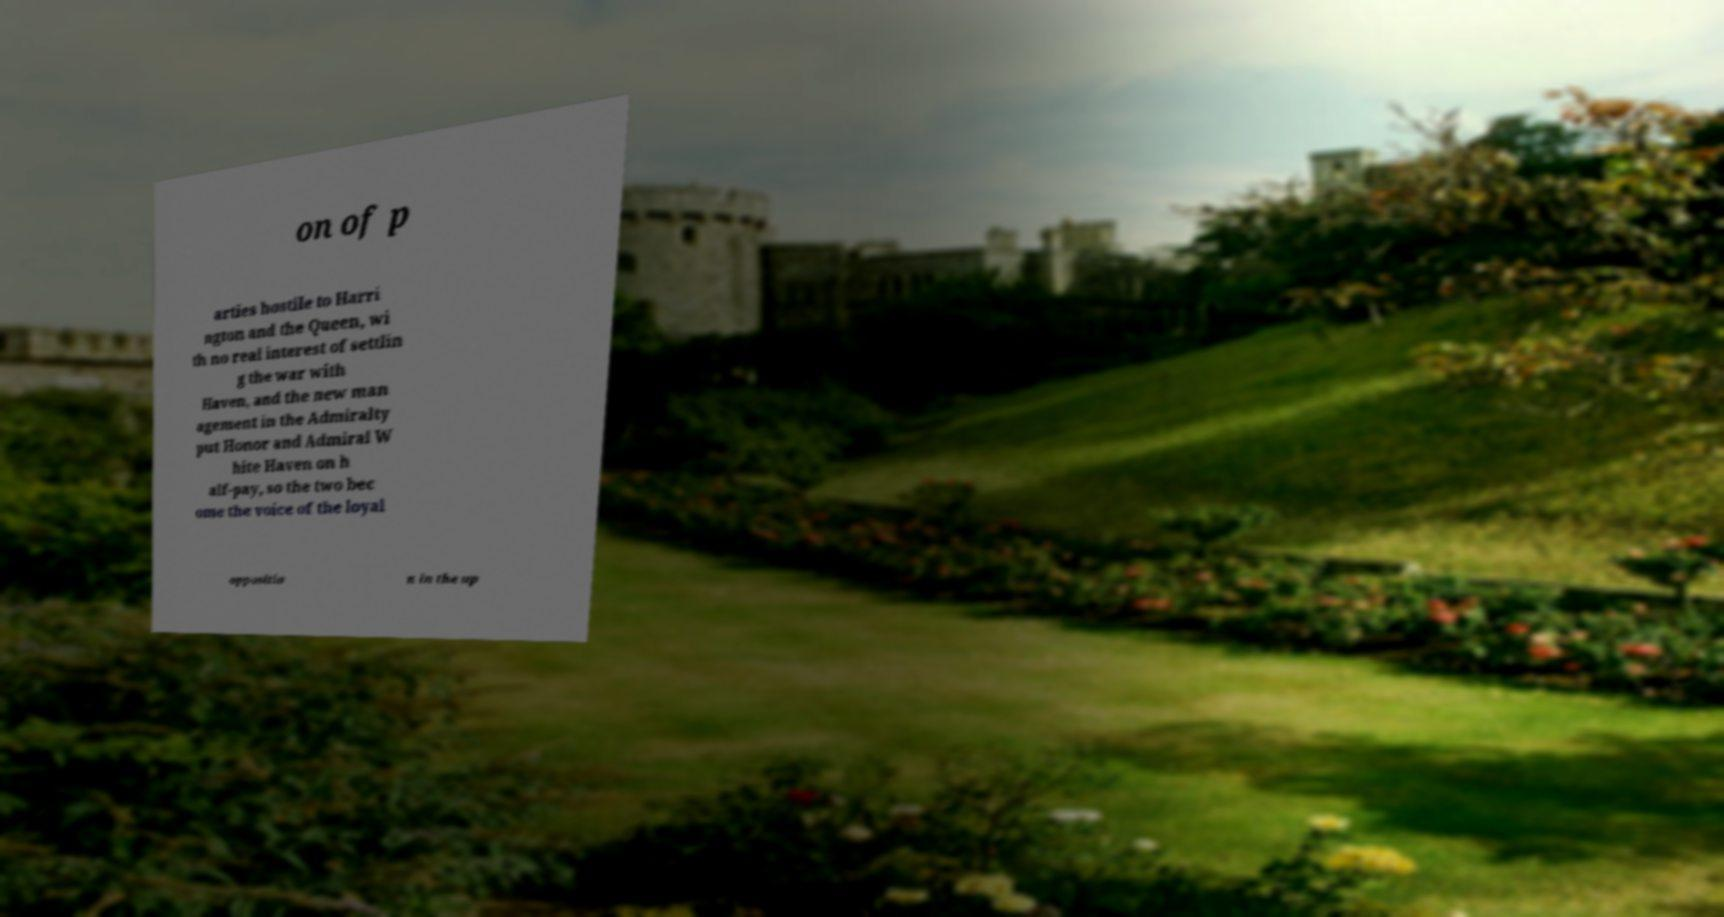Can you accurately transcribe the text from the provided image for me? on of p arties hostile to Harri ngton and the Queen, wi th no real interest of settlin g the war with Haven, and the new man agement in the Admiralty put Honor and Admiral W hite Haven on h alf-pay, so the two bec ome the voice of the loyal oppositio n in the up 